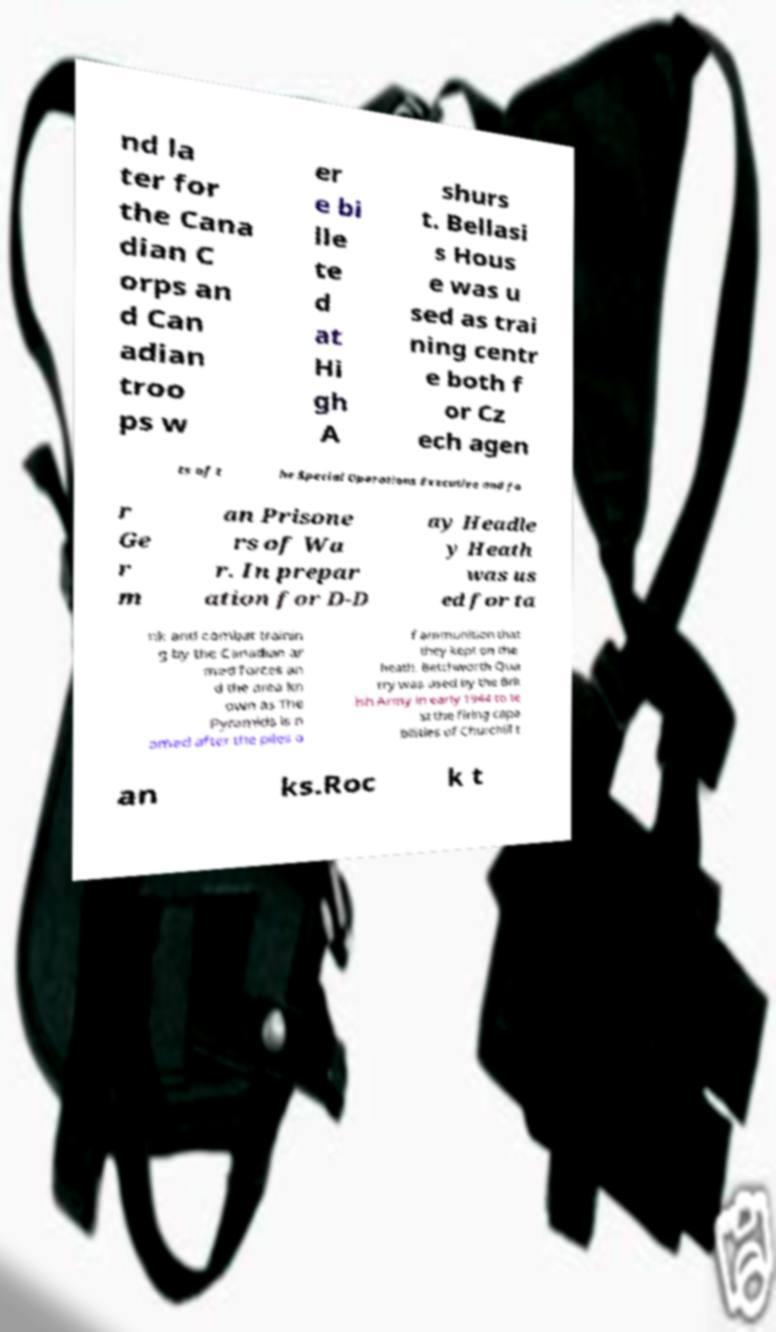Please read and relay the text visible in this image. What does it say? nd la ter for the Cana dian C orps an d Can adian troo ps w er e bi lle te d at Hi gh A shurs t. Bellasi s Hous e was u sed as trai ning centr e both f or Cz ech agen ts of t he Special Operations Executive and fo r Ge r m an Prisone rs of Wa r. In prepar ation for D-D ay Headle y Heath was us ed for ta nk and combat trainin g by the Canadian ar med forces an d the area kn own as The Pyramids is n amed after the piles o f ammunition that they kept on the heath. Betchworth Qua rry was used by the Brit ish Army in early 1944 to te st the firing capa bilities of Churchill t an ks.Roc k t 